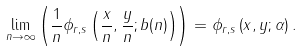Convert formula to latex. <formula><loc_0><loc_0><loc_500><loc_500>\underset { n \rightarrow \infty } { \lim } \left ( \frac { 1 } { n } \phi _ { r , s } \left ( \frac { x } { n } , \frac { y } { n } ; b ( n ) \right ) \right ) = \phi _ { r , s } \left ( x , y ; \alpha \right ) .</formula> 